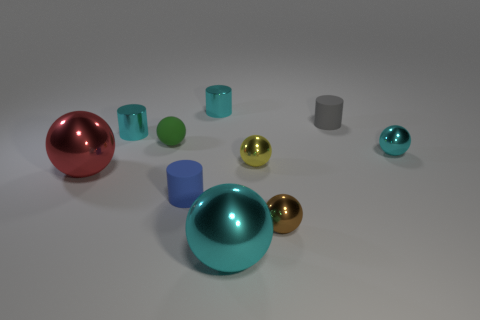Subtract 2 spheres. How many spheres are left? 4 Subtract all green balls. How many balls are left? 5 Subtract all brown metallic balls. How many balls are left? 5 Subtract all blue balls. Subtract all green cubes. How many balls are left? 6 Subtract all spheres. How many objects are left? 4 Subtract all red rubber things. Subtract all small cyan objects. How many objects are left? 7 Add 8 small cyan metallic balls. How many small cyan metallic balls are left? 9 Add 8 big red blocks. How many big red blocks exist? 8 Subtract 0 brown cubes. How many objects are left? 10 